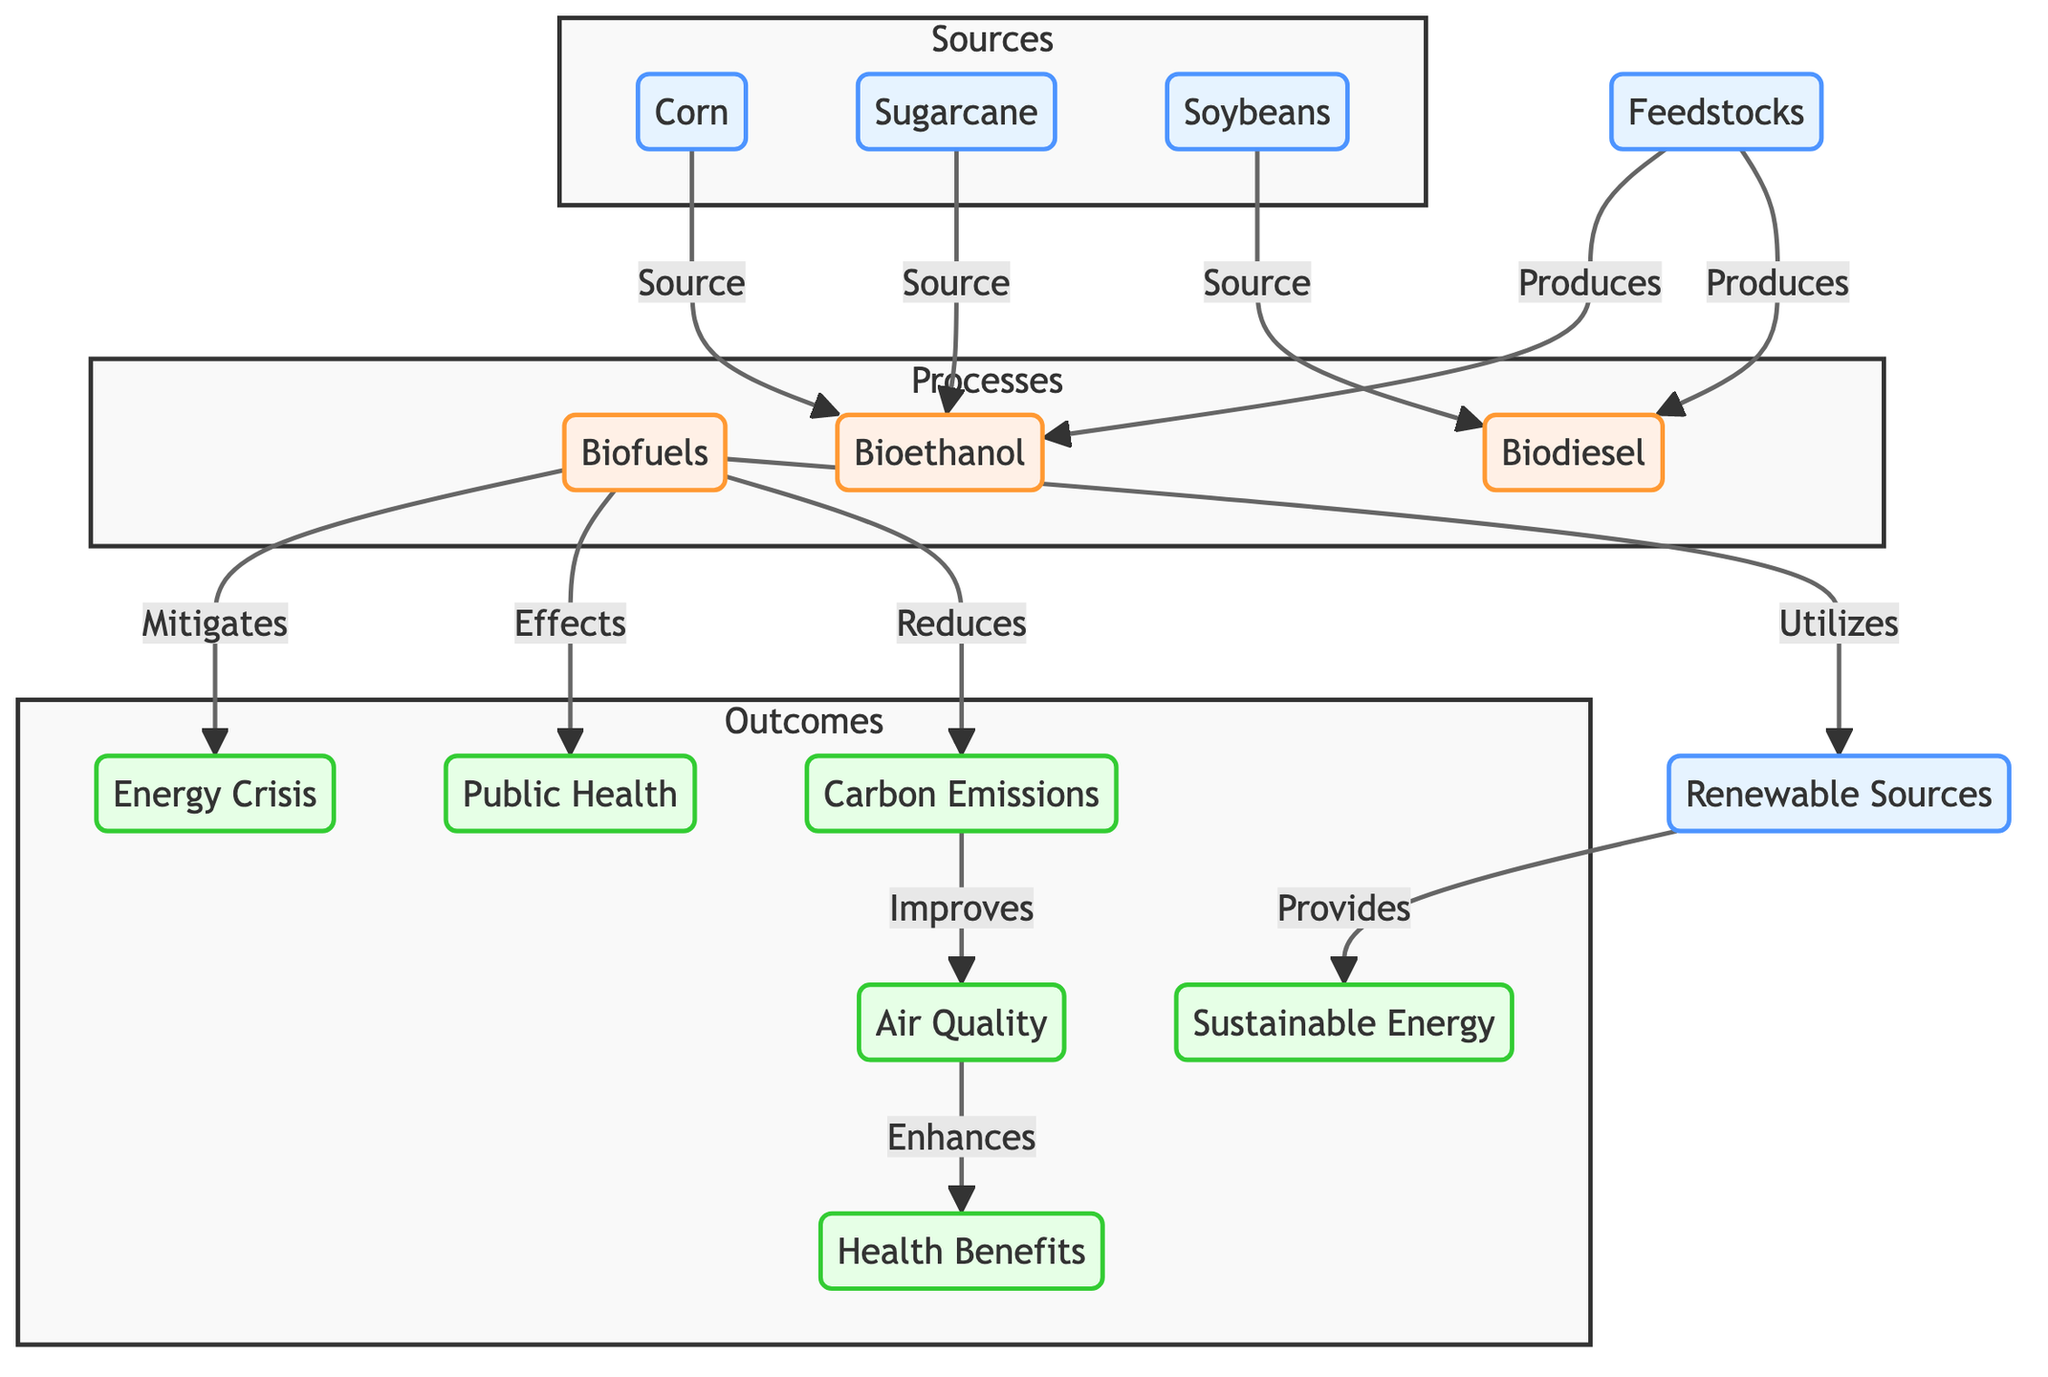What are the three types of feedstocks shown in the diagram? The diagram lists three feedstocks: corn, sugarcane, and soybeans, which are categorized under the "Sources" subgraph.
Answer: corn, sugarcane, soybeans What process do biofuels utilize to provide sustainable energy? In the diagram, biofuels utilize renewable sources to provide sustainable energy, demonstrating the flow from renewable sources to sustainable energy in the outcomes.
Answer: renewable sources How many processes are represented in this diagram? The diagram consists of three processes: biofuels, bioethanol, and biodiesel, counted from the "Processes" subgraph.
Answer: 3 What is the relationship between biofuels and carbon emissions? The diagram indicates that biofuels reduce carbon emissions, establishing a direct relationship where biofuels have a positive impact on carbon emissions by lowering them.
Answer: Reduces What is the outcome of improved air quality according to the diagram? The diagram shows that improved air quality enhances health benefits, contributing positively to public health in the outcomes section of the diagram.
Answer: health benefits Which source is specifically tied to the production of bioethanol? The diagram identifies corn and sugarcane as sources for bioethanol, indicating that both feedstocks are directly linked to this biofuel production.
Answer: corn, sugarcane How does biofuels impact the energy crisis? According to the diagram, biofuels mitigate the energy crisis, providing a direct solution to the problem illustrated in the outcome section.
Answer: Mitigates What are the effects of biofuels on public health? The diagram correlates biofuels with effects on public health by specifying that they impact health benefits through improved air quality and reduced carbon emissions, indicating their significance in health outcomes.
Answer: Effects What is produced from soybeans according to the diagram? The diagram clearly indicates that biodiesel is produced from soybeans, establishing the feedstock's role in a specific biofuel production process.
Answer: biodiesel 